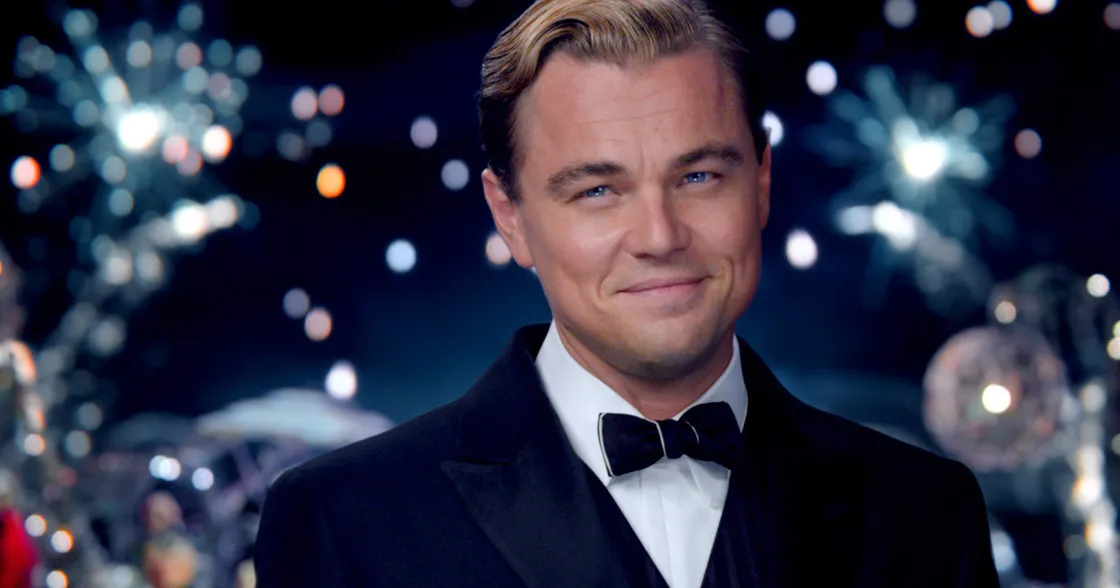Imagine this scene was part of a dream. How would you interpret it? In the realm of dreams, this scene could symbolize a desire for recognition, celebration, and the attainment of personal goals. The fireworks and lights represent a climactic moment, a peak of achievement or revelation. The character's composed and confident expression might reflect a subconscious longing for self-assurance and validation. Alternatively, it could symbolize an inner conflict between the outward display of success and the search for deeper meaning or connection. Can you create a poetic description of this image? Under skies ablaze with celestial light, he stands as the epitome of grace. Dressed in a midnight's embrace, his presence commands the night's enchanted waltz. Fireworks whisper tales of triumph, each spark a note in an opulent symphony. In his gaze, a universe of dreams unfurls, capturing the essence of fleeting grandeur. Amidst the ever-glowing celebration, he is both the author and the muse, a balance of strength and delicate allure. With a smile that bridges realms of the seen and the unseen, he transforms the moment into a timeless reverie, a beacon of elegant enigma. 